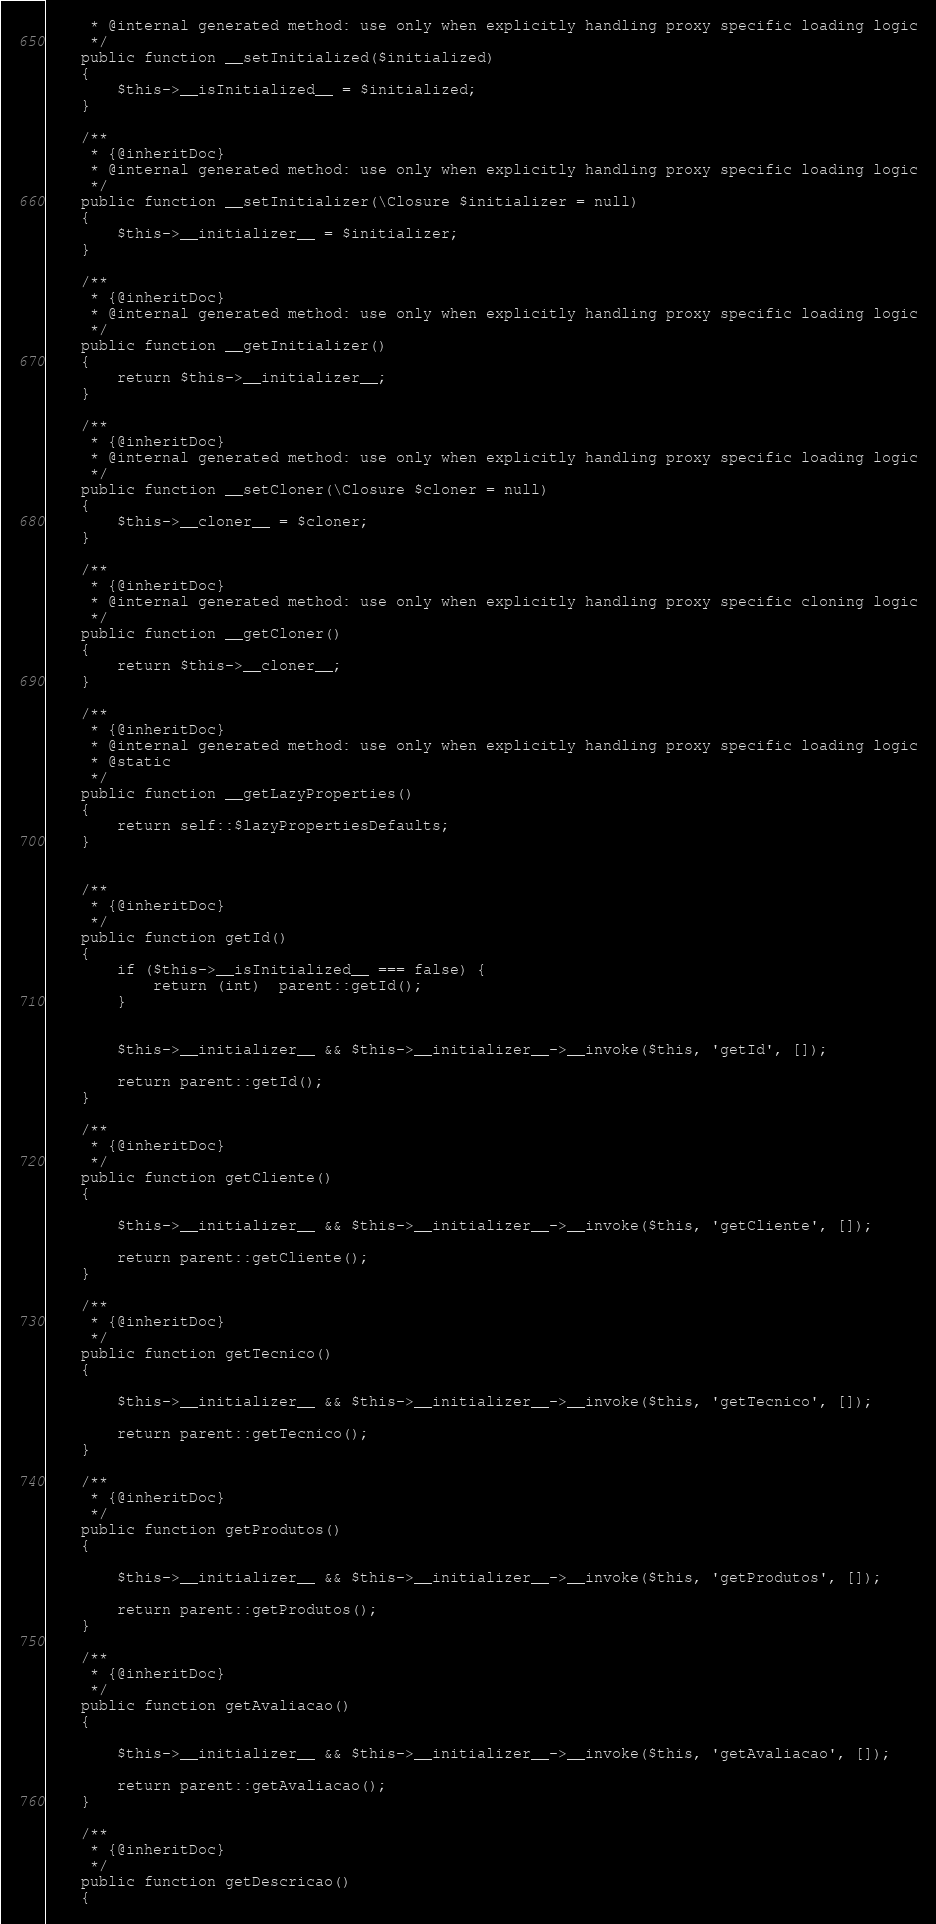Convert code to text. <code><loc_0><loc_0><loc_500><loc_500><_PHP_>     * @internal generated method: use only when explicitly handling proxy specific loading logic
     */
    public function __setInitialized($initialized)
    {
        $this->__isInitialized__ = $initialized;
    }

    /**
     * {@inheritDoc}
     * @internal generated method: use only when explicitly handling proxy specific loading logic
     */
    public function __setInitializer(\Closure $initializer = null)
    {
        $this->__initializer__ = $initializer;
    }

    /**
     * {@inheritDoc}
     * @internal generated method: use only when explicitly handling proxy specific loading logic
     */
    public function __getInitializer()
    {
        return $this->__initializer__;
    }

    /**
     * {@inheritDoc}
     * @internal generated method: use only when explicitly handling proxy specific loading logic
     */
    public function __setCloner(\Closure $cloner = null)
    {
        $this->__cloner__ = $cloner;
    }

    /**
     * {@inheritDoc}
     * @internal generated method: use only when explicitly handling proxy specific cloning logic
     */
    public function __getCloner()
    {
        return $this->__cloner__;
    }

    /**
     * {@inheritDoc}
     * @internal generated method: use only when explicitly handling proxy specific loading logic
     * @static
     */
    public function __getLazyProperties()
    {
        return self::$lazyPropertiesDefaults;
    }

    
    /**
     * {@inheritDoc}
     */
    public function getId()
    {
        if ($this->__isInitialized__ === false) {
            return (int)  parent::getId();
        }


        $this->__initializer__ && $this->__initializer__->__invoke($this, 'getId', []);

        return parent::getId();
    }

    /**
     * {@inheritDoc}
     */
    public function getCliente()
    {

        $this->__initializer__ && $this->__initializer__->__invoke($this, 'getCliente', []);

        return parent::getCliente();
    }

    /**
     * {@inheritDoc}
     */
    public function getTecnico()
    {

        $this->__initializer__ && $this->__initializer__->__invoke($this, 'getTecnico', []);

        return parent::getTecnico();
    }

    /**
     * {@inheritDoc}
     */
    public function getProdutos()
    {

        $this->__initializer__ && $this->__initializer__->__invoke($this, 'getProdutos', []);

        return parent::getProdutos();
    }

    /**
     * {@inheritDoc}
     */
    public function getAvaliacao()
    {

        $this->__initializer__ && $this->__initializer__->__invoke($this, 'getAvaliacao', []);

        return parent::getAvaliacao();
    }

    /**
     * {@inheritDoc}
     */
    public function getDescricao()
    {
</code> 